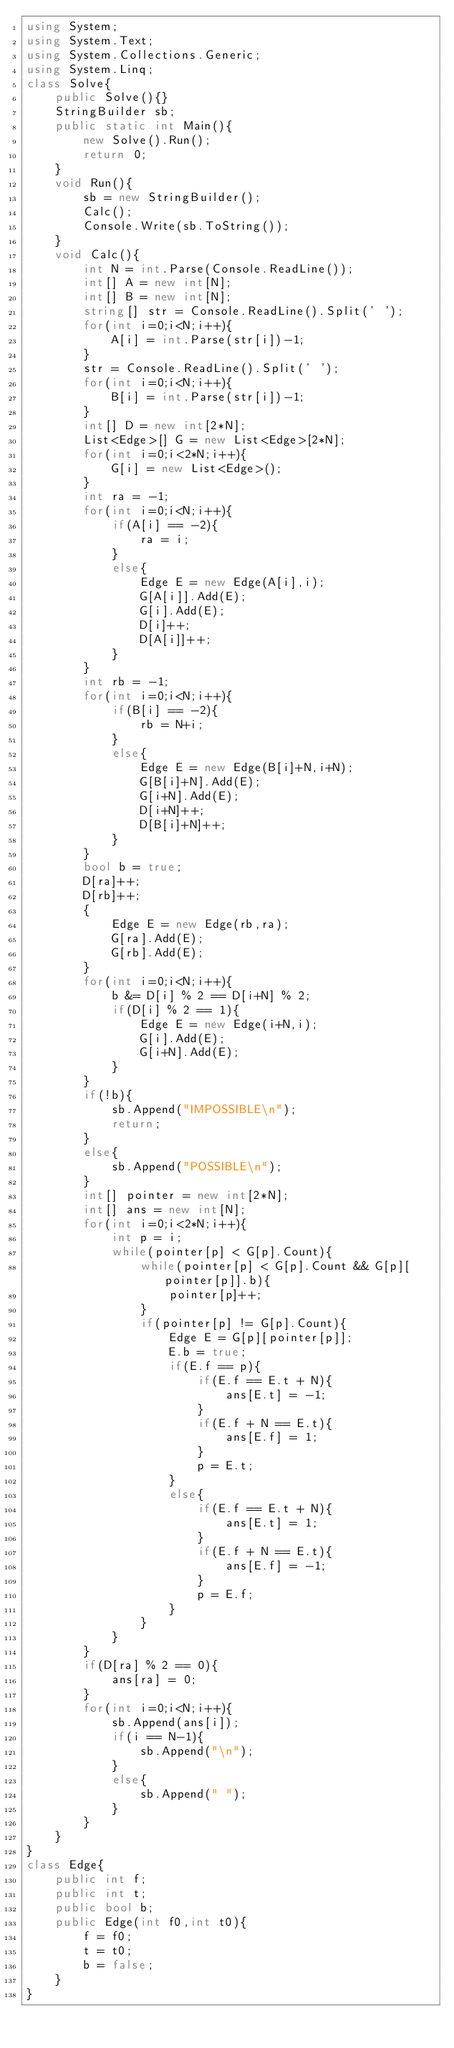Convert code to text. <code><loc_0><loc_0><loc_500><loc_500><_C#_>using System;
using System.Text;
using System.Collections.Generic;
using System.Linq;
class Solve{
    public Solve(){}
    StringBuilder sb;
    public static int Main(){
        new Solve().Run();
        return 0;
    }
    void Run(){
        sb = new StringBuilder();
        Calc();
        Console.Write(sb.ToString());
    }
    void Calc(){
        int N = int.Parse(Console.ReadLine());
        int[] A = new int[N];
        int[] B = new int[N];
        string[] str = Console.ReadLine().Split(' ');
        for(int i=0;i<N;i++){
            A[i] = int.Parse(str[i])-1;
        }
        str = Console.ReadLine().Split(' ');
        for(int i=0;i<N;i++){
            B[i] = int.Parse(str[i])-1;
        }
        int[] D = new int[2*N];
        List<Edge>[] G = new List<Edge>[2*N];
        for(int i=0;i<2*N;i++){
            G[i] = new List<Edge>();
        }
        int ra = -1;
        for(int i=0;i<N;i++){
            if(A[i] == -2){
                ra = i;
            }
            else{
                Edge E = new Edge(A[i],i);
                G[A[i]].Add(E);
                G[i].Add(E);
                D[i]++;
                D[A[i]]++;
            }
        }
        int rb = -1;
        for(int i=0;i<N;i++){
            if(B[i] == -2){
                rb = N+i;
            }
            else{
                Edge E = new Edge(B[i]+N,i+N);
                G[B[i]+N].Add(E);
                G[i+N].Add(E);
                D[i+N]++;
                D[B[i]+N]++;
            }
        }
        bool b = true;
        D[ra]++;
        D[rb]++;
        {
            Edge E = new Edge(rb,ra);
            G[ra].Add(E);
            G[rb].Add(E);
        }
        for(int i=0;i<N;i++){
            b &= D[i] % 2 == D[i+N] % 2;
            if(D[i] % 2 == 1){
                Edge E = new Edge(i+N,i);
                G[i].Add(E);
                G[i+N].Add(E);
            }
        }
        if(!b){
            sb.Append("IMPOSSIBLE\n");
            return;
        }
        else{
            sb.Append("POSSIBLE\n");
        }
        int[] pointer = new int[2*N];
        int[] ans = new int[N];
        for(int i=0;i<2*N;i++){
            int p = i;
            while(pointer[p] < G[p].Count){
                while(pointer[p] < G[p].Count && G[p][pointer[p]].b){
                    pointer[p]++;
                }
                if(pointer[p] != G[p].Count){
                    Edge E = G[p][pointer[p]];
                    E.b = true;
                    if(E.f == p){
                        if(E.f == E.t + N){
                            ans[E.t] = -1;
                        }
                        if(E.f + N == E.t){
                            ans[E.f] = 1;
                        }
                        p = E.t;
                    }
                    else{
                        if(E.f == E.t + N){
                            ans[E.t] = 1;
                        }
                        if(E.f + N == E.t){
                            ans[E.f] = -1;
                        }
                        p = E.f;
                    }
                }
            }
        }
        if(D[ra] % 2 == 0){
            ans[ra] = 0;
        }
        for(int i=0;i<N;i++){
            sb.Append(ans[i]);
            if(i == N-1){
                sb.Append("\n");
            }
            else{
                sb.Append(" ");
            }
        }
    }
}
class Edge{
    public int f;
    public int t;
    public bool b;
    public Edge(int f0,int t0){
        f = f0;
        t = t0;
        b = false;
    }
}</code> 